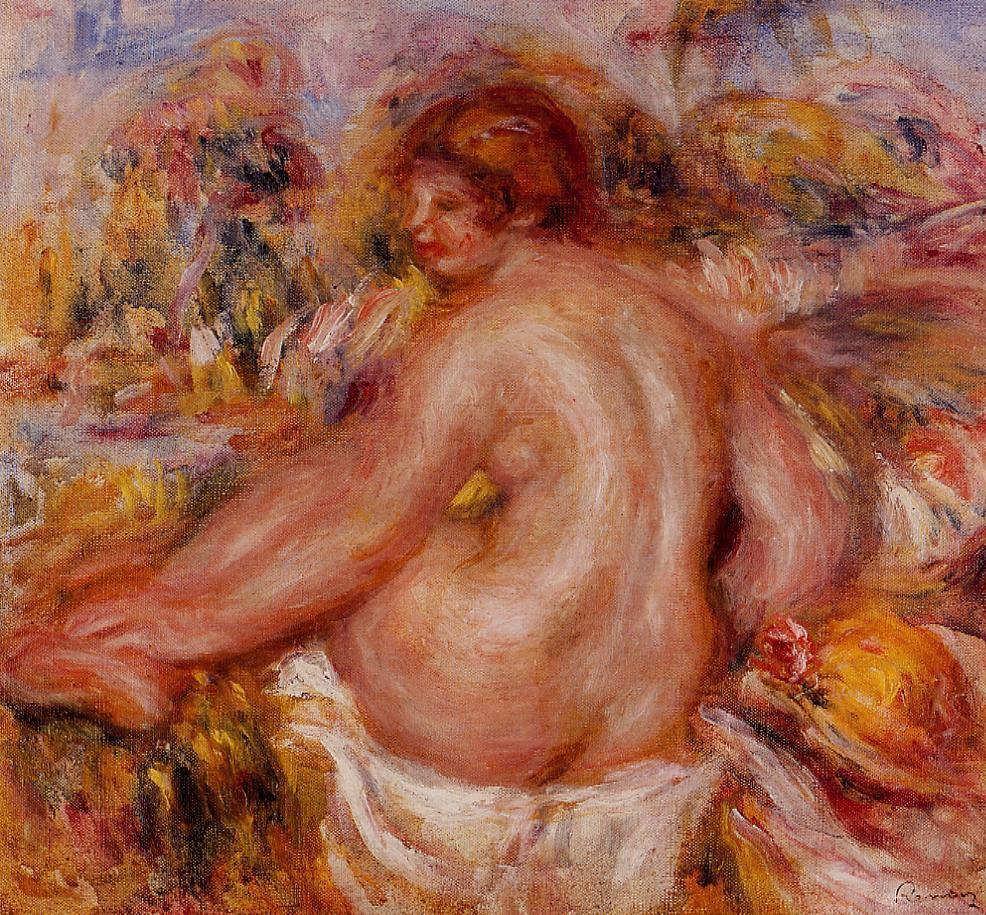If this painting could speak, what would it say? If this painting could speak, it might share a message of harmony and peace: 'Embrace the beauty of the natural world and find solace in its embrace. Let the warmth of the sun and the vibrant colors of life fill you with tranquility and joy. In this moment, be still, and feel the connection to the earth, to yourself, and to the fleeting, yet eternal, wonders of existence.' Describe a day in the life of the woman depicted in this painting. Isabelle lives in a quaint cottage on the edge of a picturesque village. Her days begin with the gentle light of dawn streaming through her window, stirring her from her slumber. She rises, dons a simple dress, and steps barefoot into her beloved garden, where she tends to her flowers, speaking to them as if they were old friends. Her mornings are filled with the scent of blooming roses and the soft hum of bees.

As the day progresses, Isabelle escapes into her garden's hidden nook, a personal oasis where she can express herself freely. She often sits amidst the flowers, letting the sun warm her skin and the fragrance of petals envelop her. In these moments, she feels a profound sense of connection to the world around her, a harmony that transcends words.

Towards the evening, she finds inspiration to paint, capturing the colors and emotions of the day onto canvas. Her art reflects the beauty she sees in the world and her deep, intrinsic connection to nature. As night falls, Isabelle retires with a heart full of gratitude, knowing that she will awaken to another day of simple, profound beauty. 